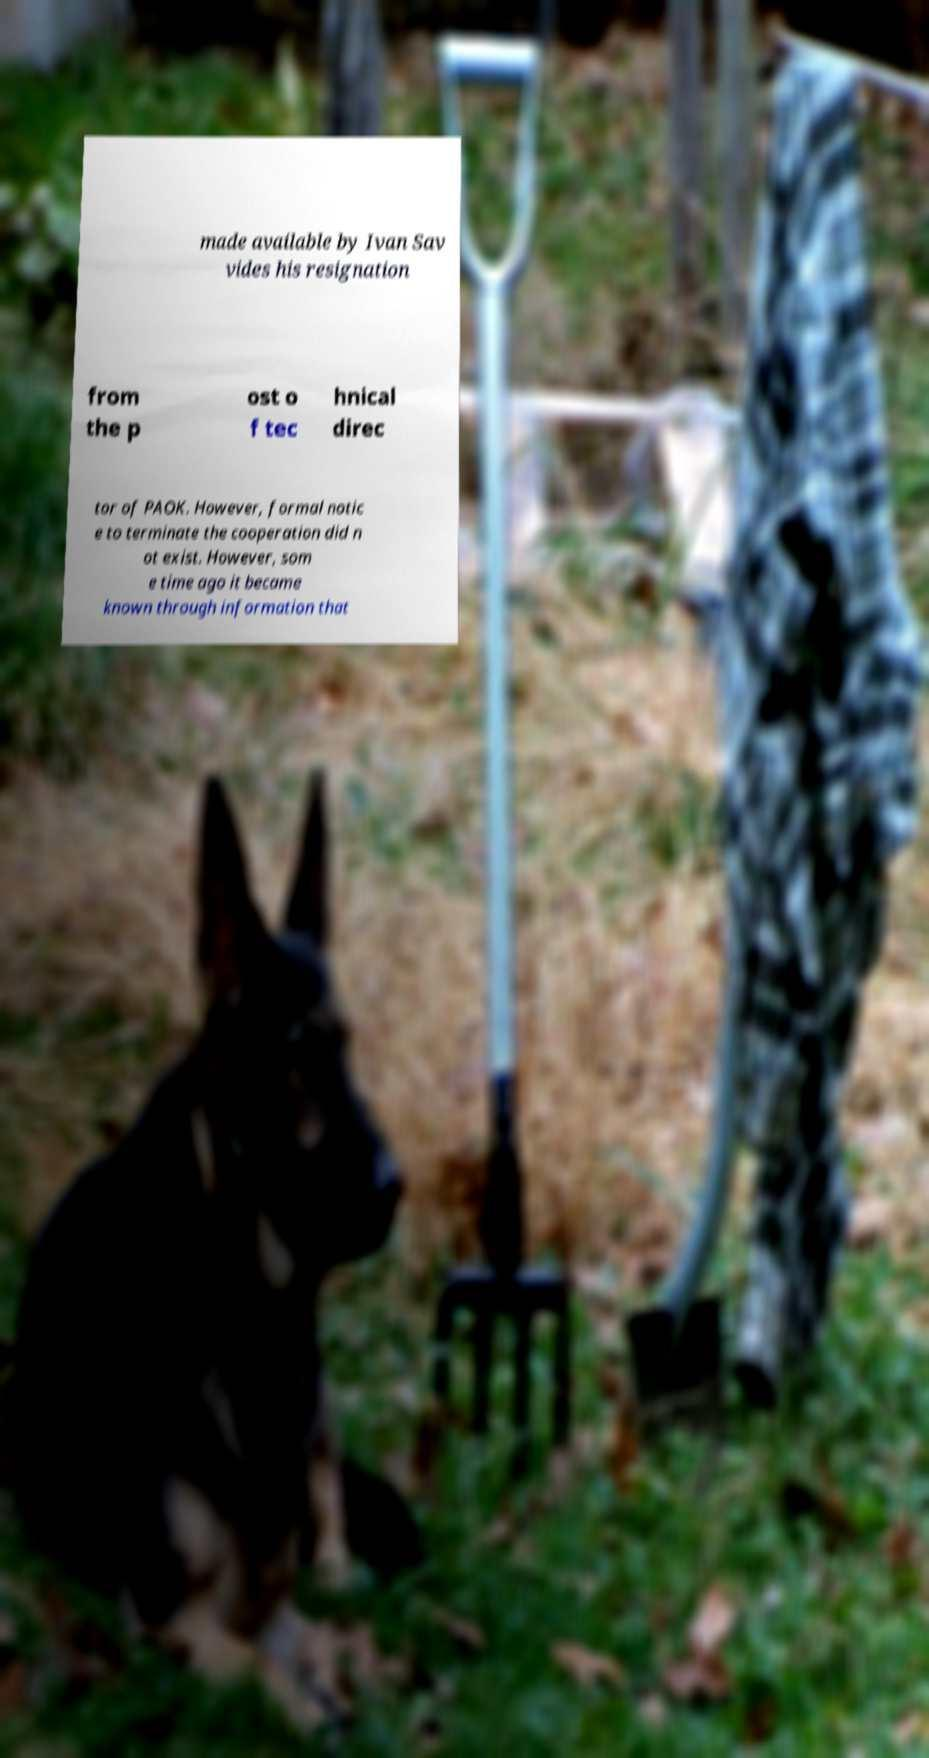What seems to be the context or setting of the scene in which the text is placed? The image shows a blurred background featuring outdoor elements like a shovel, fence, and what appears to be a garden or yard. The foreground focuses on a paper with printed text. This juxtaposition could imply that the message is being 'unearthed' or revealed in a literal or symbolic excavation. 